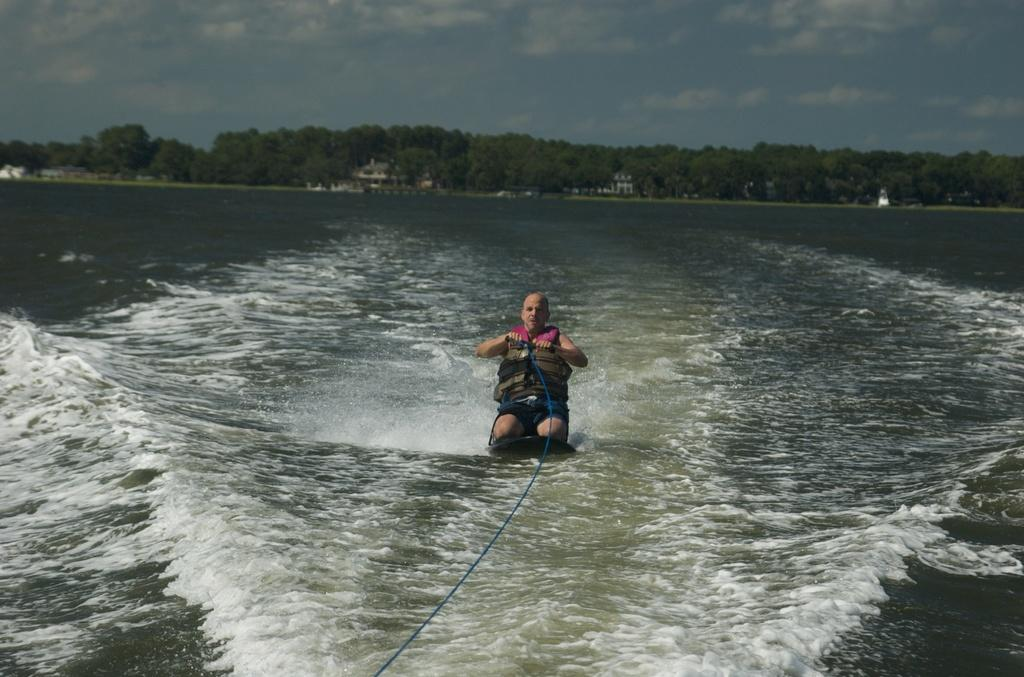What is the location of the image? The image is taken near a river. What is the person in the image doing? The person is sitting on a board in the center of the image. What is the person holding? The person is holding a rope. What can be seen in the background of the image? There are trees and the sky with clouds visible in the background of the image. What type of poison is the person using to control the force of the jeans in the image? There is no mention of poison, force, or jeans in the image. The person is holding a rope while sitting on a board near a river. 